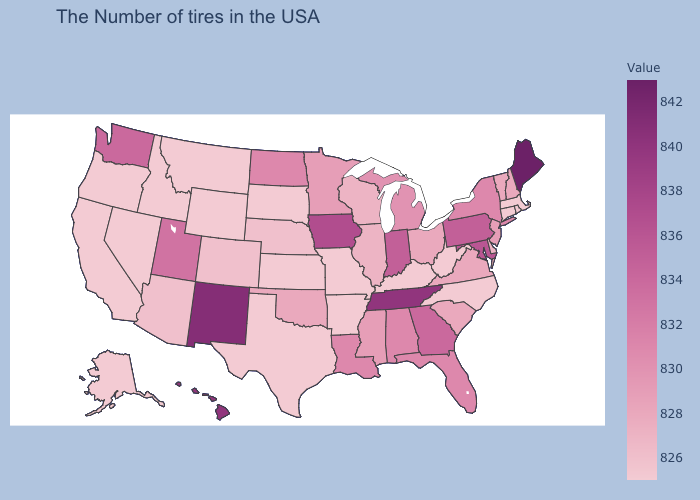Does Texas have the lowest value in the USA?
Concise answer only. Yes. Which states have the highest value in the USA?
Quick response, please. Maine. Does Mississippi have a lower value than Texas?
Concise answer only. No. Does Mississippi have a lower value than Florida?
Be succinct. Yes. Is the legend a continuous bar?
Answer briefly. Yes. 